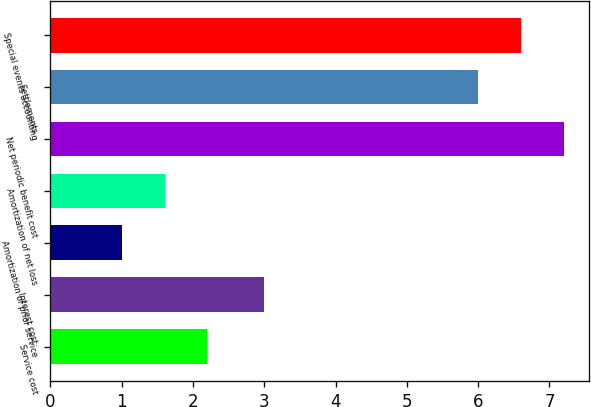Convert chart to OTSL. <chart><loc_0><loc_0><loc_500><loc_500><bar_chart><fcel>Service cost<fcel>Interest cost<fcel>Amortization of prior service<fcel>Amortization of net loss<fcel>Net periodic benefit cost<fcel>Settlements<fcel>Special events accounting<nl><fcel>2.2<fcel>3<fcel>1<fcel>1.6<fcel>7.2<fcel>6<fcel>6.6<nl></chart> 